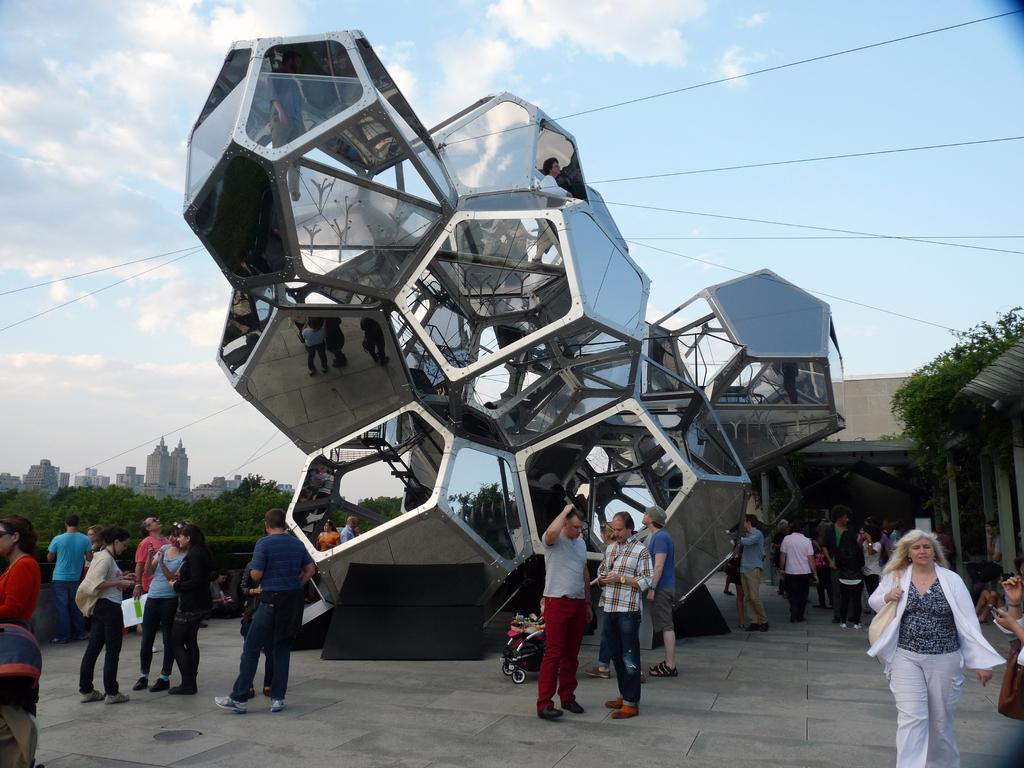Please provide a concise description of this image. In this picture we can see a group of people standing on the ground, stroller, trees, buildings and in the background we can see the sky with clouds. 